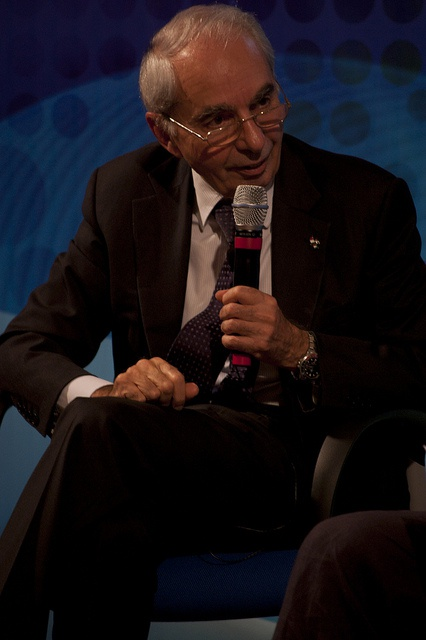Describe the objects in this image and their specific colors. I can see people in black, maroon, gray, and brown tones, people in black, gray, and darkblue tones, tie in black, maroon, brown, and gray tones, and chair in black, maroon, and brown tones in this image. 